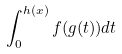Convert formula to latex. <formula><loc_0><loc_0><loc_500><loc_500>\int _ { 0 } ^ { h ( x ) } f ( g ( t ) ) d t</formula> 